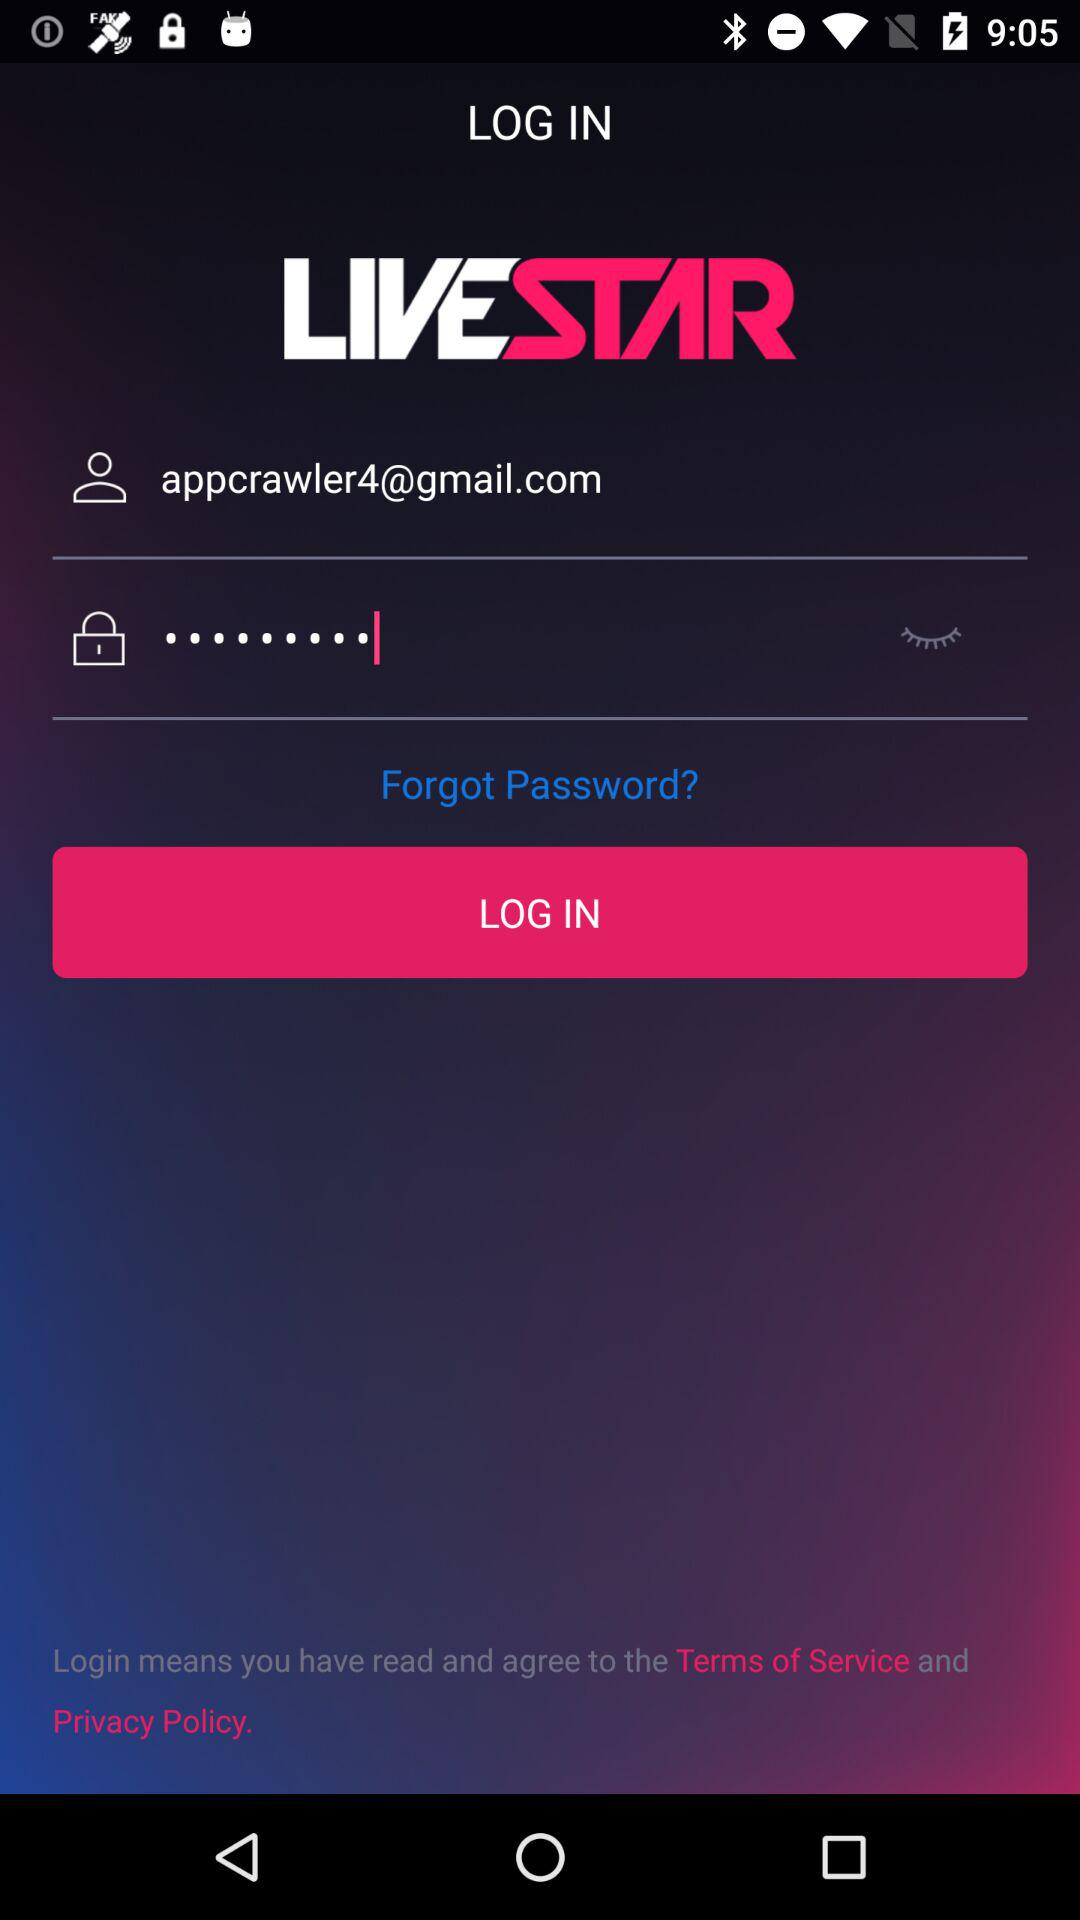What is the name of the application? The name of the application is "LIVESTAR". 